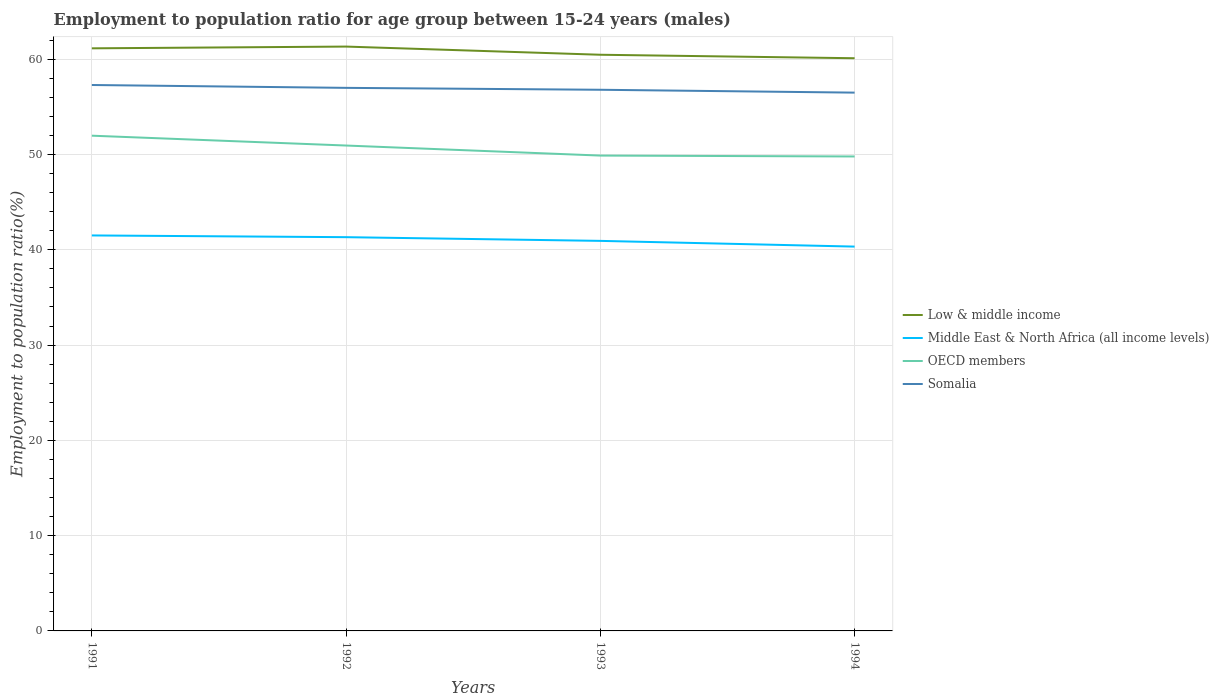How many different coloured lines are there?
Your response must be concise. 4. Is the number of lines equal to the number of legend labels?
Give a very brief answer. Yes. Across all years, what is the maximum employment to population ratio in Middle East & North Africa (all income levels)?
Ensure brevity in your answer.  40.34. What is the total employment to population ratio in OECD members in the graph?
Ensure brevity in your answer.  0.09. What is the difference between the highest and the second highest employment to population ratio in OECD members?
Keep it short and to the point. 2.18. What is the difference between the highest and the lowest employment to population ratio in OECD members?
Keep it short and to the point. 2. Is the employment to population ratio in OECD members strictly greater than the employment to population ratio in Low & middle income over the years?
Give a very brief answer. Yes. How many years are there in the graph?
Offer a terse response. 4. What is the difference between two consecutive major ticks on the Y-axis?
Ensure brevity in your answer.  10. Does the graph contain grids?
Provide a succinct answer. Yes. How are the legend labels stacked?
Keep it short and to the point. Vertical. What is the title of the graph?
Your answer should be compact. Employment to population ratio for age group between 15-24 years (males). What is the label or title of the X-axis?
Provide a short and direct response. Years. What is the Employment to population ratio(%) in Low & middle income in 1991?
Keep it short and to the point. 61.15. What is the Employment to population ratio(%) in Middle East & North Africa (all income levels) in 1991?
Keep it short and to the point. 41.51. What is the Employment to population ratio(%) in OECD members in 1991?
Your response must be concise. 51.98. What is the Employment to population ratio(%) in Somalia in 1991?
Provide a succinct answer. 57.3. What is the Employment to population ratio(%) in Low & middle income in 1992?
Provide a short and direct response. 61.33. What is the Employment to population ratio(%) in Middle East & North Africa (all income levels) in 1992?
Keep it short and to the point. 41.33. What is the Employment to population ratio(%) of OECD members in 1992?
Your response must be concise. 50.95. What is the Employment to population ratio(%) in Somalia in 1992?
Provide a short and direct response. 57. What is the Employment to population ratio(%) in Low & middle income in 1993?
Your answer should be compact. 60.48. What is the Employment to population ratio(%) of Middle East & North Africa (all income levels) in 1993?
Ensure brevity in your answer.  40.94. What is the Employment to population ratio(%) of OECD members in 1993?
Give a very brief answer. 49.89. What is the Employment to population ratio(%) in Somalia in 1993?
Keep it short and to the point. 56.8. What is the Employment to population ratio(%) of Low & middle income in 1994?
Your response must be concise. 60.11. What is the Employment to population ratio(%) in Middle East & North Africa (all income levels) in 1994?
Offer a terse response. 40.34. What is the Employment to population ratio(%) in OECD members in 1994?
Make the answer very short. 49.8. What is the Employment to population ratio(%) in Somalia in 1994?
Offer a very short reply. 56.5. Across all years, what is the maximum Employment to population ratio(%) of Low & middle income?
Make the answer very short. 61.33. Across all years, what is the maximum Employment to population ratio(%) of Middle East & North Africa (all income levels)?
Keep it short and to the point. 41.51. Across all years, what is the maximum Employment to population ratio(%) of OECD members?
Your answer should be very brief. 51.98. Across all years, what is the maximum Employment to population ratio(%) of Somalia?
Give a very brief answer. 57.3. Across all years, what is the minimum Employment to population ratio(%) of Low & middle income?
Offer a very short reply. 60.11. Across all years, what is the minimum Employment to population ratio(%) of Middle East & North Africa (all income levels)?
Offer a terse response. 40.34. Across all years, what is the minimum Employment to population ratio(%) in OECD members?
Ensure brevity in your answer.  49.8. Across all years, what is the minimum Employment to population ratio(%) in Somalia?
Your response must be concise. 56.5. What is the total Employment to population ratio(%) in Low & middle income in the graph?
Your response must be concise. 243.07. What is the total Employment to population ratio(%) in Middle East & North Africa (all income levels) in the graph?
Ensure brevity in your answer.  164.12. What is the total Employment to population ratio(%) of OECD members in the graph?
Provide a succinct answer. 202.62. What is the total Employment to population ratio(%) of Somalia in the graph?
Ensure brevity in your answer.  227.6. What is the difference between the Employment to population ratio(%) of Low & middle income in 1991 and that in 1992?
Give a very brief answer. -0.18. What is the difference between the Employment to population ratio(%) of Middle East & North Africa (all income levels) in 1991 and that in 1992?
Provide a short and direct response. 0.18. What is the difference between the Employment to population ratio(%) in OECD members in 1991 and that in 1992?
Ensure brevity in your answer.  1.03. What is the difference between the Employment to population ratio(%) in Somalia in 1991 and that in 1992?
Offer a very short reply. 0.3. What is the difference between the Employment to population ratio(%) of Low & middle income in 1991 and that in 1993?
Keep it short and to the point. 0.67. What is the difference between the Employment to population ratio(%) in Middle East & North Africa (all income levels) in 1991 and that in 1993?
Your response must be concise. 0.57. What is the difference between the Employment to population ratio(%) of OECD members in 1991 and that in 1993?
Provide a short and direct response. 2.09. What is the difference between the Employment to population ratio(%) of Middle East & North Africa (all income levels) in 1991 and that in 1994?
Provide a succinct answer. 1.17. What is the difference between the Employment to population ratio(%) of OECD members in 1991 and that in 1994?
Your answer should be very brief. 2.18. What is the difference between the Employment to population ratio(%) of Low & middle income in 1992 and that in 1993?
Keep it short and to the point. 0.86. What is the difference between the Employment to population ratio(%) in Middle East & North Africa (all income levels) in 1992 and that in 1993?
Your response must be concise. 0.39. What is the difference between the Employment to population ratio(%) in OECD members in 1992 and that in 1993?
Your response must be concise. 1.05. What is the difference between the Employment to population ratio(%) of Somalia in 1992 and that in 1993?
Offer a terse response. 0.2. What is the difference between the Employment to population ratio(%) of Low & middle income in 1992 and that in 1994?
Your answer should be compact. 1.22. What is the difference between the Employment to population ratio(%) of Middle East & North Africa (all income levels) in 1992 and that in 1994?
Make the answer very short. 0.99. What is the difference between the Employment to population ratio(%) of OECD members in 1992 and that in 1994?
Provide a short and direct response. 1.15. What is the difference between the Employment to population ratio(%) of Somalia in 1992 and that in 1994?
Make the answer very short. 0.5. What is the difference between the Employment to population ratio(%) of Low & middle income in 1993 and that in 1994?
Offer a terse response. 0.37. What is the difference between the Employment to population ratio(%) of Middle East & North Africa (all income levels) in 1993 and that in 1994?
Your answer should be very brief. 0.6. What is the difference between the Employment to population ratio(%) in OECD members in 1993 and that in 1994?
Provide a succinct answer. 0.09. What is the difference between the Employment to population ratio(%) of Somalia in 1993 and that in 1994?
Offer a terse response. 0.3. What is the difference between the Employment to population ratio(%) of Low & middle income in 1991 and the Employment to population ratio(%) of Middle East & North Africa (all income levels) in 1992?
Give a very brief answer. 19.82. What is the difference between the Employment to population ratio(%) of Low & middle income in 1991 and the Employment to population ratio(%) of OECD members in 1992?
Your answer should be very brief. 10.2. What is the difference between the Employment to population ratio(%) of Low & middle income in 1991 and the Employment to population ratio(%) of Somalia in 1992?
Offer a terse response. 4.15. What is the difference between the Employment to population ratio(%) in Middle East & North Africa (all income levels) in 1991 and the Employment to population ratio(%) in OECD members in 1992?
Your response must be concise. -9.44. What is the difference between the Employment to population ratio(%) of Middle East & North Africa (all income levels) in 1991 and the Employment to population ratio(%) of Somalia in 1992?
Offer a terse response. -15.49. What is the difference between the Employment to population ratio(%) in OECD members in 1991 and the Employment to population ratio(%) in Somalia in 1992?
Offer a very short reply. -5.02. What is the difference between the Employment to population ratio(%) of Low & middle income in 1991 and the Employment to population ratio(%) of Middle East & North Africa (all income levels) in 1993?
Provide a succinct answer. 20.21. What is the difference between the Employment to population ratio(%) of Low & middle income in 1991 and the Employment to population ratio(%) of OECD members in 1993?
Keep it short and to the point. 11.26. What is the difference between the Employment to population ratio(%) of Low & middle income in 1991 and the Employment to population ratio(%) of Somalia in 1993?
Make the answer very short. 4.35. What is the difference between the Employment to population ratio(%) of Middle East & North Africa (all income levels) in 1991 and the Employment to population ratio(%) of OECD members in 1993?
Offer a terse response. -8.38. What is the difference between the Employment to population ratio(%) in Middle East & North Africa (all income levels) in 1991 and the Employment to population ratio(%) in Somalia in 1993?
Offer a terse response. -15.29. What is the difference between the Employment to population ratio(%) in OECD members in 1991 and the Employment to population ratio(%) in Somalia in 1993?
Ensure brevity in your answer.  -4.82. What is the difference between the Employment to population ratio(%) in Low & middle income in 1991 and the Employment to population ratio(%) in Middle East & North Africa (all income levels) in 1994?
Offer a terse response. 20.81. What is the difference between the Employment to population ratio(%) of Low & middle income in 1991 and the Employment to population ratio(%) of OECD members in 1994?
Your response must be concise. 11.35. What is the difference between the Employment to population ratio(%) in Low & middle income in 1991 and the Employment to population ratio(%) in Somalia in 1994?
Your answer should be very brief. 4.65. What is the difference between the Employment to population ratio(%) in Middle East & North Africa (all income levels) in 1991 and the Employment to population ratio(%) in OECD members in 1994?
Your answer should be compact. -8.29. What is the difference between the Employment to population ratio(%) in Middle East & North Africa (all income levels) in 1991 and the Employment to population ratio(%) in Somalia in 1994?
Your answer should be very brief. -14.99. What is the difference between the Employment to population ratio(%) in OECD members in 1991 and the Employment to population ratio(%) in Somalia in 1994?
Give a very brief answer. -4.52. What is the difference between the Employment to population ratio(%) of Low & middle income in 1992 and the Employment to population ratio(%) of Middle East & North Africa (all income levels) in 1993?
Your answer should be compact. 20.39. What is the difference between the Employment to population ratio(%) in Low & middle income in 1992 and the Employment to population ratio(%) in OECD members in 1993?
Give a very brief answer. 11.44. What is the difference between the Employment to population ratio(%) in Low & middle income in 1992 and the Employment to population ratio(%) in Somalia in 1993?
Your answer should be very brief. 4.53. What is the difference between the Employment to population ratio(%) of Middle East & North Africa (all income levels) in 1992 and the Employment to population ratio(%) of OECD members in 1993?
Your answer should be very brief. -8.56. What is the difference between the Employment to population ratio(%) in Middle East & North Africa (all income levels) in 1992 and the Employment to population ratio(%) in Somalia in 1993?
Provide a succinct answer. -15.47. What is the difference between the Employment to population ratio(%) of OECD members in 1992 and the Employment to population ratio(%) of Somalia in 1993?
Your answer should be compact. -5.85. What is the difference between the Employment to population ratio(%) in Low & middle income in 1992 and the Employment to population ratio(%) in Middle East & North Africa (all income levels) in 1994?
Your answer should be very brief. 20.99. What is the difference between the Employment to population ratio(%) in Low & middle income in 1992 and the Employment to population ratio(%) in OECD members in 1994?
Make the answer very short. 11.53. What is the difference between the Employment to population ratio(%) in Low & middle income in 1992 and the Employment to population ratio(%) in Somalia in 1994?
Make the answer very short. 4.83. What is the difference between the Employment to population ratio(%) of Middle East & North Africa (all income levels) in 1992 and the Employment to population ratio(%) of OECD members in 1994?
Provide a succinct answer. -8.47. What is the difference between the Employment to population ratio(%) of Middle East & North Africa (all income levels) in 1992 and the Employment to population ratio(%) of Somalia in 1994?
Offer a very short reply. -15.17. What is the difference between the Employment to population ratio(%) in OECD members in 1992 and the Employment to population ratio(%) in Somalia in 1994?
Offer a very short reply. -5.55. What is the difference between the Employment to population ratio(%) of Low & middle income in 1993 and the Employment to population ratio(%) of Middle East & North Africa (all income levels) in 1994?
Give a very brief answer. 20.14. What is the difference between the Employment to population ratio(%) in Low & middle income in 1993 and the Employment to population ratio(%) in OECD members in 1994?
Your answer should be very brief. 10.68. What is the difference between the Employment to population ratio(%) in Low & middle income in 1993 and the Employment to population ratio(%) in Somalia in 1994?
Your answer should be compact. 3.98. What is the difference between the Employment to population ratio(%) in Middle East & North Africa (all income levels) in 1993 and the Employment to population ratio(%) in OECD members in 1994?
Give a very brief answer. -8.86. What is the difference between the Employment to population ratio(%) in Middle East & North Africa (all income levels) in 1993 and the Employment to population ratio(%) in Somalia in 1994?
Keep it short and to the point. -15.56. What is the difference between the Employment to population ratio(%) of OECD members in 1993 and the Employment to population ratio(%) of Somalia in 1994?
Give a very brief answer. -6.61. What is the average Employment to population ratio(%) in Low & middle income per year?
Make the answer very short. 60.77. What is the average Employment to population ratio(%) in Middle East & North Africa (all income levels) per year?
Your answer should be very brief. 41.03. What is the average Employment to population ratio(%) of OECD members per year?
Give a very brief answer. 50.65. What is the average Employment to population ratio(%) of Somalia per year?
Offer a very short reply. 56.9. In the year 1991, what is the difference between the Employment to population ratio(%) of Low & middle income and Employment to population ratio(%) of Middle East & North Africa (all income levels)?
Your answer should be compact. 19.64. In the year 1991, what is the difference between the Employment to population ratio(%) in Low & middle income and Employment to population ratio(%) in OECD members?
Provide a short and direct response. 9.17. In the year 1991, what is the difference between the Employment to population ratio(%) in Low & middle income and Employment to population ratio(%) in Somalia?
Offer a very short reply. 3.85. In the year 1991, what is the difference between the Employment to population ratio(%) of Middle East & North Africa (all income levels) and Employment to population ratio(%) of OECD members?
Provide a short and direct response. -10.47. In the year 1991, what is the difference between the Employment to population ratio(%) in Middle East & North Africa (all income levels) and Employment to population ratio(%) in Somalia?
Your answer should be compact. -15.79. In the year 1991, what is the difference between the Employment to population ratio(%) in OECD members and Employment to population ratio(%) in Somalia?
Offer a terse response. -5.32. In the year 1992, what is the difference between the Employment to population ratio(%) of Low & middle income and Employment to population ratio(%) of Middle East & North Africa (all income levels)?
Ensure brevity in your answer.  20.01. In the year 1992, what is the difference between the Employment to population ratio(%) in Low & middle income and Employment to population ratio(%) in OECD members?
Your answer should be very brief. 10.39. In the year 1992, what is the difference between the Employment to population ratio(%) in Low & middle income and Employment to population ratio(%) in Somalia?
Provide a short and direct response. 4.33. In the year 1992, what is the difference between the Employment to population ratio(%) in Middle East & North Africa (all income levels) and Employment to population ratio(%) in OECD members?
Provide a succinct answer. -9.62. In the year 1992, what is the difference between the Employment to population ratio(%) of Middle East & North Africa (all income levels) and Employment to population ratio(%) of Somalia?
Your response must be concise. -15.67. In the year 1992, what is the difference between the Employment to population ratio(%) of OECD members and Employment to population ratio(%) of Somalia?
Ensure brevity in your answer.  -6.05. In the year 1993, what is the difference between the Employment to population ratio(%) of Low & middle income and Employment to population ratio(%) of Middle East & North Africa (all income levels)?
Give a very brief answer. 19.54. In the year 1993, what is the difference between the Employment to population ratio(%) in Low & middle income and Employment to population ratio(%) in OECD members?
Ensure brevity in your answer.  10.58. In the year 1993, what is the difference between the Employment to population ratio(%) of Low & middle income and Employment to population ratio(%) of Somalia?
Your response must be concise. 3.68. In the year 1993, what is the difference between the Employment to population ratio(%) of Middle East & North Africa (all income levels) and Employment to population ratio(%) of OECD members?
Make the answer very short. -8.95. In the year 1993, what is the difference between the Employment to population ratio(%) of Middle East & North Africa (all income levels) and Employment to population ratio(%) of Somalia?
Offer a terse response. -15.86. In the year 1993, what is the difference between the Employment to population ratio(%) of OECD members and Employment to population ratio(%) of Somalia?
Keep it short and to the point. -6.91. In the year 1994, what is the difference between the Employment to population ratio(%) of Low & middle income and Employment to population ratio(%) of Middle East & North Africa (all income levels)?
Your answer should be very brief. 19.77. In the year 1994, what is the difference between the Employment to population ratio(%) in Low & middle income and Employment to population ratio(%) in OECD members?
Provide a succinct answer. 10.31. In the year 1994, what is the difference between the Employment to population ratio(%) in Low & middle income and Employment to population ratio(%) in Somalia?
Keep it short and to the point. 3.61. In the year 1994, what is the difference between the Employment to population ratio(%) of Middle East & North Africa (all income levels) and Employment to population ratio(%) of OECD members?
Ensure brevity in your answer.  -9.46. In the year 1994, what is the difference between the Employment to population ratio(%) in Middle East & North Africa (all income levels) and Employment to population ratio(%) in Somalia?
Your response must be concise. -16.16. In the year 1994, what is the difference between the Employment to population ratio(%) in OECD members and Employment to population ratio(%) in Somalia?
Provide a succinct answer. -6.7. What is the ratio of the Employment to population ratio(%) in Middle East & North Africa (all income levels) in 1991 to that in 1992?
Make the answer very short. 1. What is the ratio of the Employment to population ratio(%) in OECD members in 1991 to that in 1992?
Give a very brief answer. 1.02. What is the ratio of the Employment to population ratio(%) of Somalia in 1991 to that in 1992?
Your response must be concise. 1.01. What is the ratio of the Employment to population ratio(%) of Low & middle income in 1991 to that in 1993?
Your response must be concise. 1.01. What is the ratio of the Employment to population ratio(%) in Middle East & North Africa (all income levels) in 1991 to that in 1993?
Your answer should be compact. 1.01. What is the ratio of the Employment to population ratio(%) in OECD members in 1991 to that in 1993?
Offer a terse response. 1.04. What is the ratio of the Employment to population ratio(%) of Somalia in 1991 to that in 1993?
Make the answer very short. 1.01. What is the ratio of the Employment to population ratio(%) of Low & middle income in 1991 to that in 1994?
Provide a short and direct response. 1.02. What is the ratio of the Employment to population ratio(%) in Middle East & North Africa (all income levels) in 1991 to that in 1994?
Your answer should be compact. 1.03. What is the ratio of the Employment to population ratio(%) of OECD members in 1991 to that in 1994?
Make the answer very short. 1.04. What is the ratio of the Employment to population ratio(%) of Somalia in 1991 to that in 1994?
Offer a terse response. 1.01. What is the ratio of the Employment to population ratio(%) in Low & middle income in 1992 to that in 1993?
Give a very brief answer. 1.01. What is the ratio of the Employment to population ratio(%) of Middle East & North Africa (all income levels) in 1992 to that in 1993?
Ensure brevity in your answer.  1.01. What is the ratio of the Employment to population ratio(%) in OECD members in 1992 to that in 1993?
Provide a short and direct response. 1.02. What is the ratio of the Employment to population ratio(%) in Somalia in 1992 to that in 1993?
Your response must be concise. 1. What is the ratio of the Employment to population ratio(%) in Low & middle income in 1992 to that in 1994?
Offer a terse response. 1.02. What is the ratio of the Employment to population ratio(%) of Middle East & North Africa (all income levels) in 1992 to that in 1994?
Provide a short and direct response. 1.02. What is the ratio of the Employment to population ratio(%) of OECD members in 1992 to that in 1994?
Provide a short and direct response. 1.02. What is the ratio of the Employment to population ratio(%) in Somalia in 1992 to that in 1994?
Provide a succinct answer. 1.01. What is the ratio of the Employment to population ratio(%) in Low & middle income in 1993 to that in 1994?
Your answer should be compact. 1.01. What is the ratio of the Employment to population ratio(%) in Middle East & North Africa (all income levels) in 1993 to that in 1994?
Keep it short and to the point. 1.01. What is the ratio of the Employment to population ratio(%) in OECD members in 1993 to that in 1994?
Your answer should be compact. 1. What is the ratio of the Employment to population ratio(%) in Somalia in 1993 to that in 1994?
Provide a succinct answer. 1.01. What is the difference between the highest and the second highest Employment to population ratio(%) in Low & middle income?
Make the answer very short. 0.18. What is the difference between the highest and the second highest Employment to population ratio(%) of Middle East & North Africa (all income levels)?
Your answer should be very brief. 0.18. What is the difference between the highest and the second highest Employment to population ratio(%) of OECD members?
Make the answer very short. 1.03. What is the difference between the highest and the lowest Employment to population ratio(%) of Low & middle income?
Your answer should be very brief. 1.22. What is the difference between the highest and the lowest Employment to population ratio(%) in Middle East & North Africa (all income levels)?
Your response must be concise. 1.17. What is the difference between the highest and the lowest Employment to population ratio(%) of OECD members?
Your response must be concise. 2.18. What is the difference between the highest and the lowest Employment to population ratio(%) of Somalia?
Offer a terse response. 0.8. 